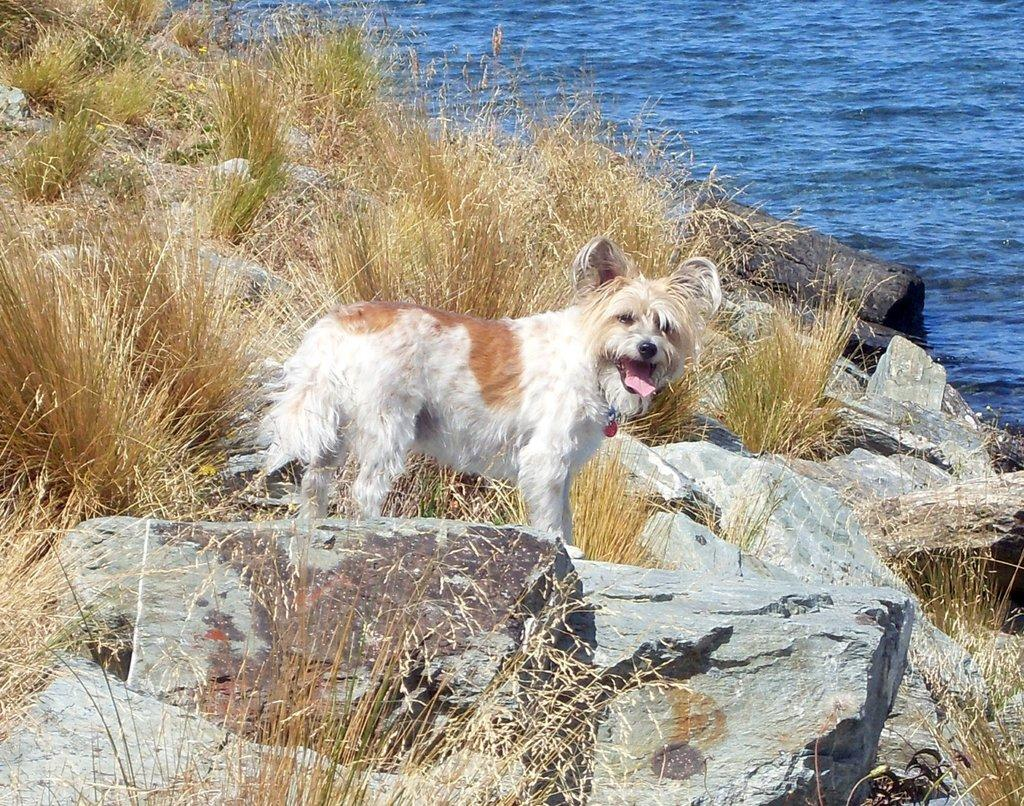What is the main subject in the center of the image? There is a dog in the center of the image. Where is the dog located? The dog is on the rocks. What type of vegetation can be seen in the image? There is dry grass in the image. What can be seen in the background of the image? There is water visible in the background of the image. What type of paint is being used by the cattle in the image? There are no cattle or paint present in the image; it features a dog on the rocks with dry grass and water in the background. 